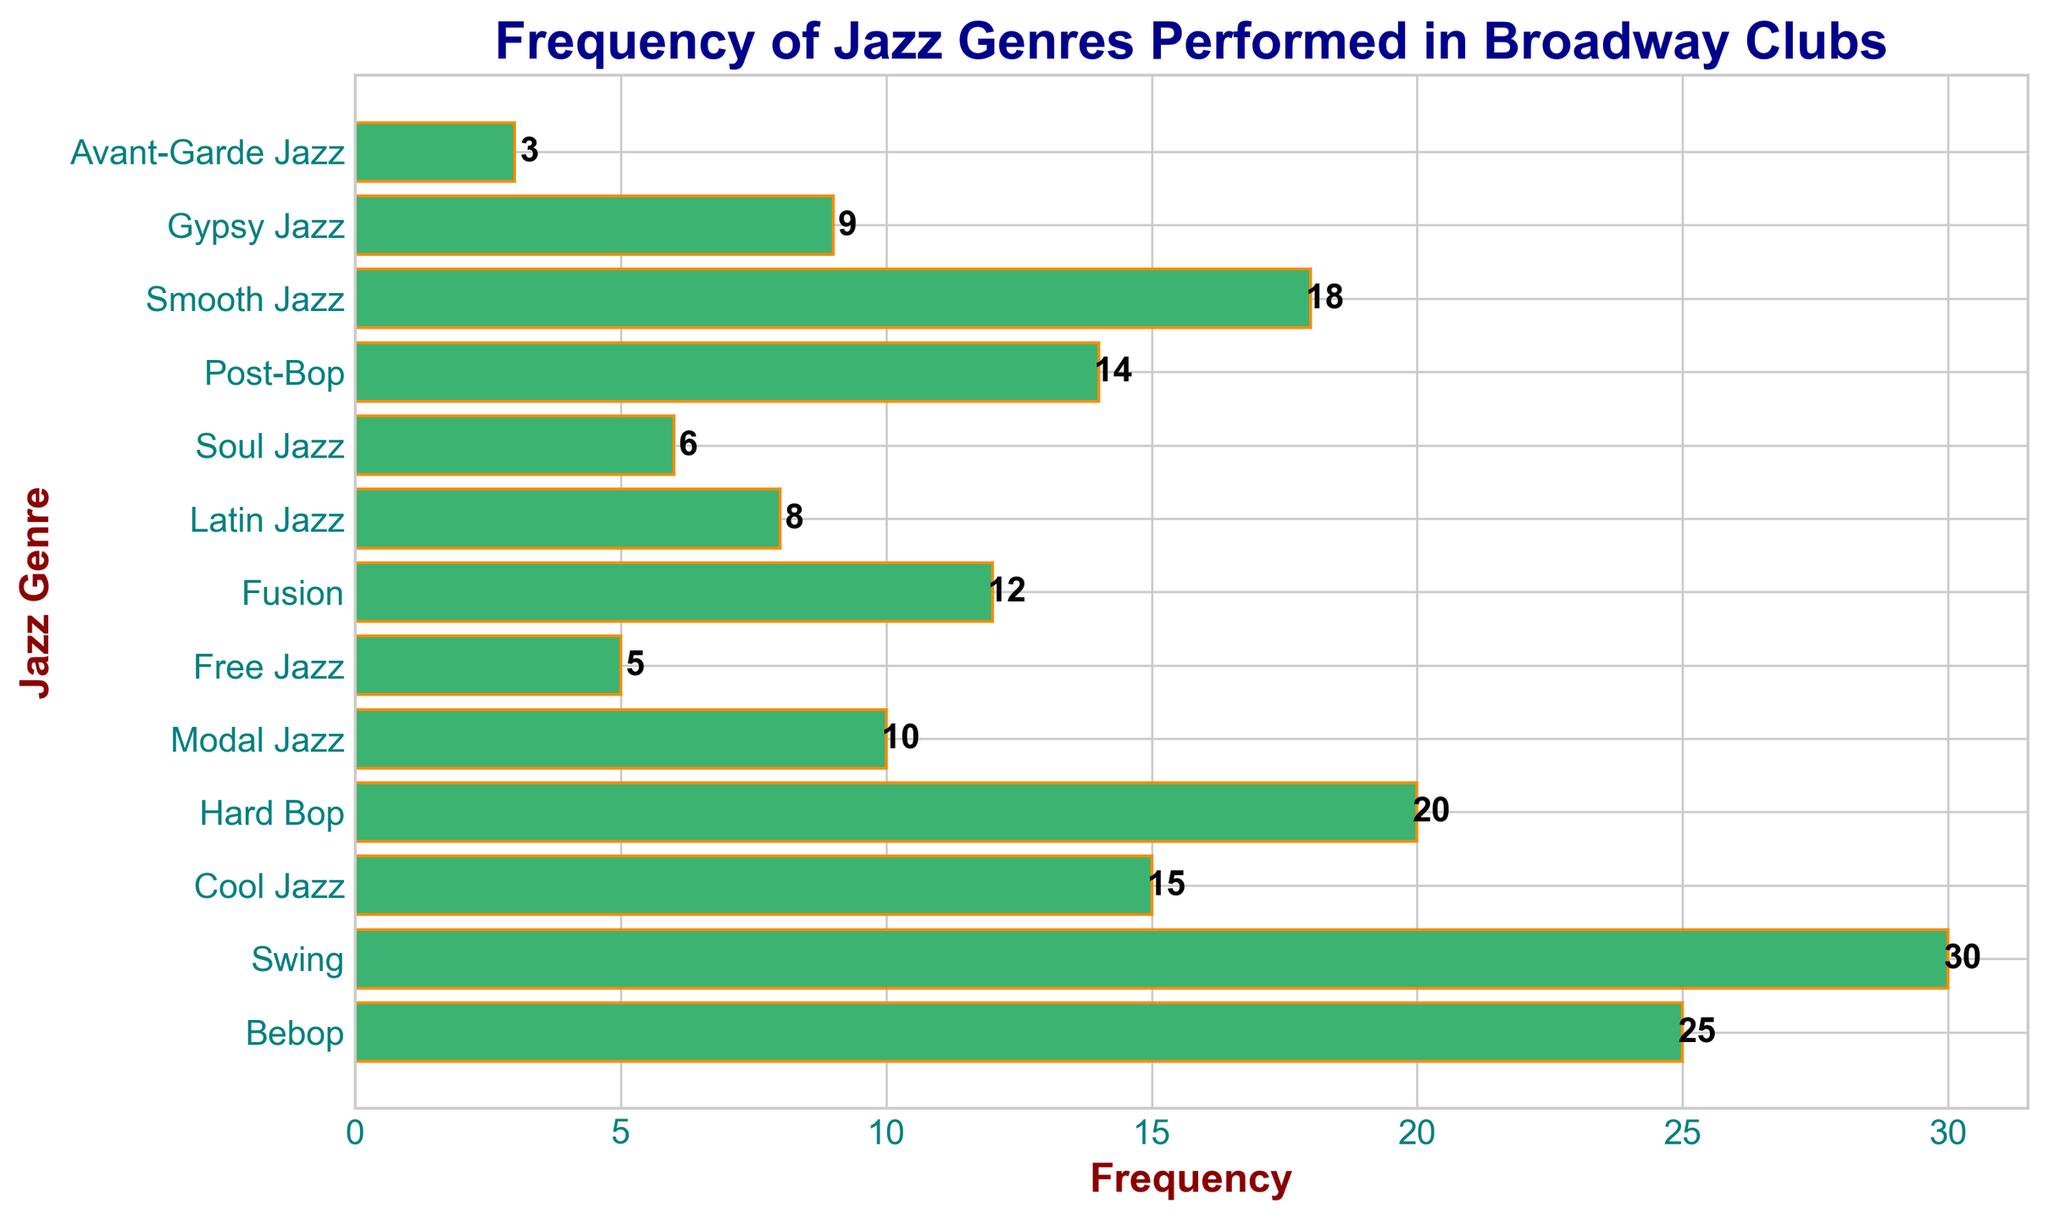What's the most frequently performed jazz genre in Broadway clubs? The genre with the highest frequency bar is 'Swing', reaching up to 30.
Answer: Swing Which jazz genres have a frequency equal to or below 10? The bars corresponding to the frequencies 10 and below are 'Modal Jazz', 'Free Jazz', 'Latin Jazz', 'Soul Jazz', and 'Avant-Garde Jazz', their frequencies being 10, 5, 8, 6, and 3 respectively.
Answer: Modal Jazz, Free Jazz, Latin Jazz, Soul Jazz, Avant-Garde Jazz How many more times is Bebop performed compared to Free Jazz? The frequency of Bebop is 25 and Free Jazz is 5. The difference is 25 - 5 = 20.
Answer: 20 What is the total frequency of genres that have a frequency greater than or equal to 15? The genres with frequency 15 and above are 'Bebop' (25), 'Swing' (30), 'Cool Jazz' (15), 'Hard Bop' (20), and 'Smooth Jazz' (18). Summing these gives: 25 + 30 + 15 + 20 + 18 = 108.
Answer: 108 Which jazz genre has a frequency closest to the average frequency of the dataset? First calculate the average frequency: (25 + 30 + 15 + 20 + 10 + 5 + 12 + 8 + 6 + 14 + 18 + 9 + 3)/13 ≈ 14.15. The genre closest to this average is 'Cool Jazz' with a frequency of 15.
Answer: Cool Jazz Among 'Fusion' and 'Gypsy Jazz', which genre is performed more frequently and by how much? The frequency of 'Fusion' is 12, and for 'Gypsy Jazz' it's 9. The difference is 12 - 9 = 3.
Answer: Fusion, 3 What’s the cumulative frequency of Hard Bop and Bebop? The frequency of 'Hard Bop' is 20, and 'Bebop' is 25. Adding these gives 20 + 25 = 45.
Answer: 45 Identify the genre with the second-highest performance frequency. The genre with the second-highest frequency is 'Bebop' with 25, after 'Swing' which has 30.
Answer: Bebop Which color is used to represent the bars in the chart? All the bars are colored 'mediumseagreen' with 'darkorange' edges.
Answer: mediumseagreen with darkorange edges 